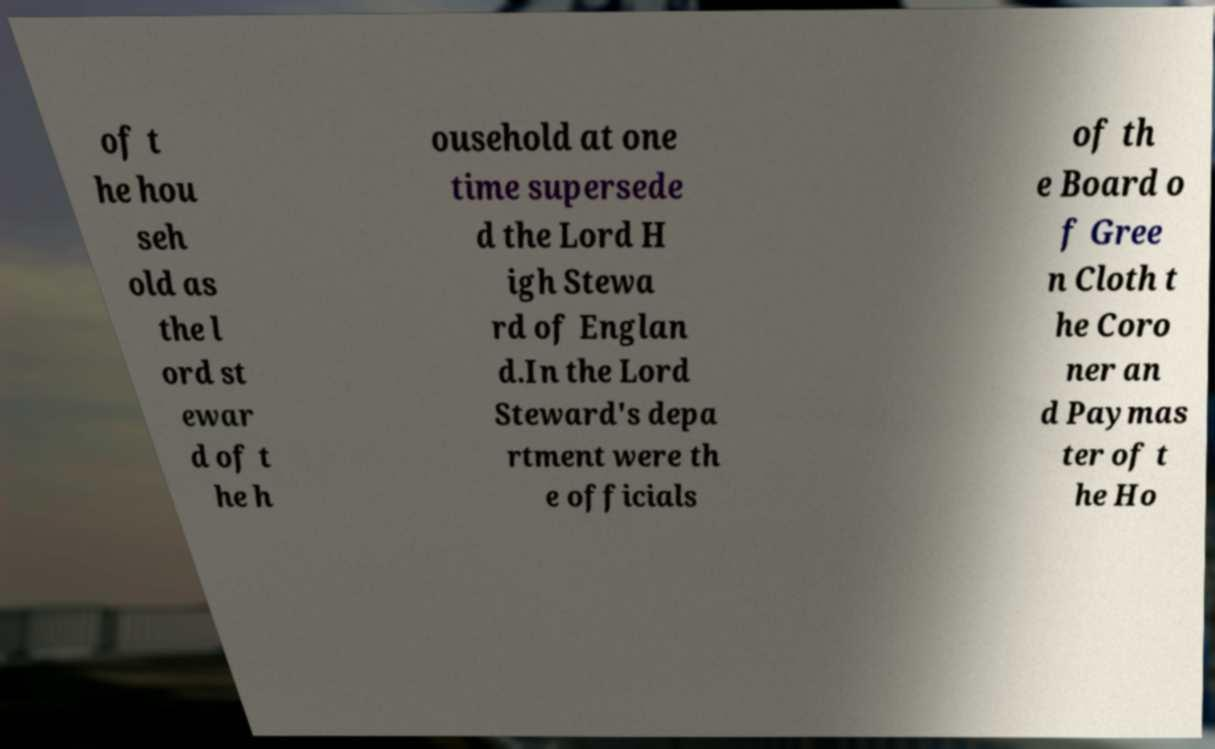I need the written content from this picture converted into text. Can you do that? of t he hou seh old as the l ord st ewar d of t he h ousehold at one time supersede d the Lord H igh Stewa rd of Englan d.In the Lord Steward's depa rtment were th e officials of th e Board o f Gree n Cloth t he Coro ner an d Paymas ter of t he Ho 